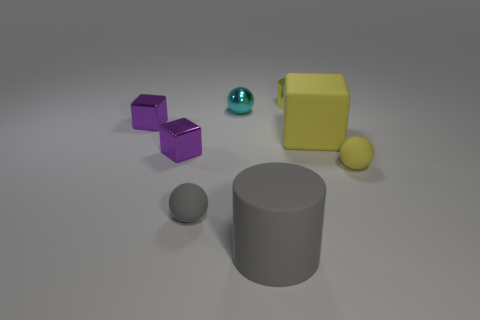Do the large block and the shiny cylinder have the same color?
Provide a succinct answer. Yes. What material is the small cylinder that is the same color as the rubber cube?
Offer a very short reply. Metal. There is a rubber sphere right of the metallic ball; what size is it?
Your response must be concise. Small. What number of things are gray shiny objects or small matte things that are right of the yellow metallic cylinder?
Offer a very short reply. 1. What number of other things are the same size as the yellow metallic cylinder?
Provide a succinct answer. 5. There is a gray thing that is the same shape as the tiny cyan metal object; what material is it?
Ensure brevity in your answer.  Rubber. Are there more yellow spheres in front of the small cylinder than green rubber cylinders?
Your answer should be very brief. Yes. Is there anything else of the same color as the tiny cylinder?
Offer a terse response. Yes. The big gray object that is the same material as the yellow ball is what shape?
Provide a succinct answer. Cylinder. Is the small ball that is behind the large yellow cube made of the same material as the yellow cylinder?
Your answer should be very brief. Yes. 